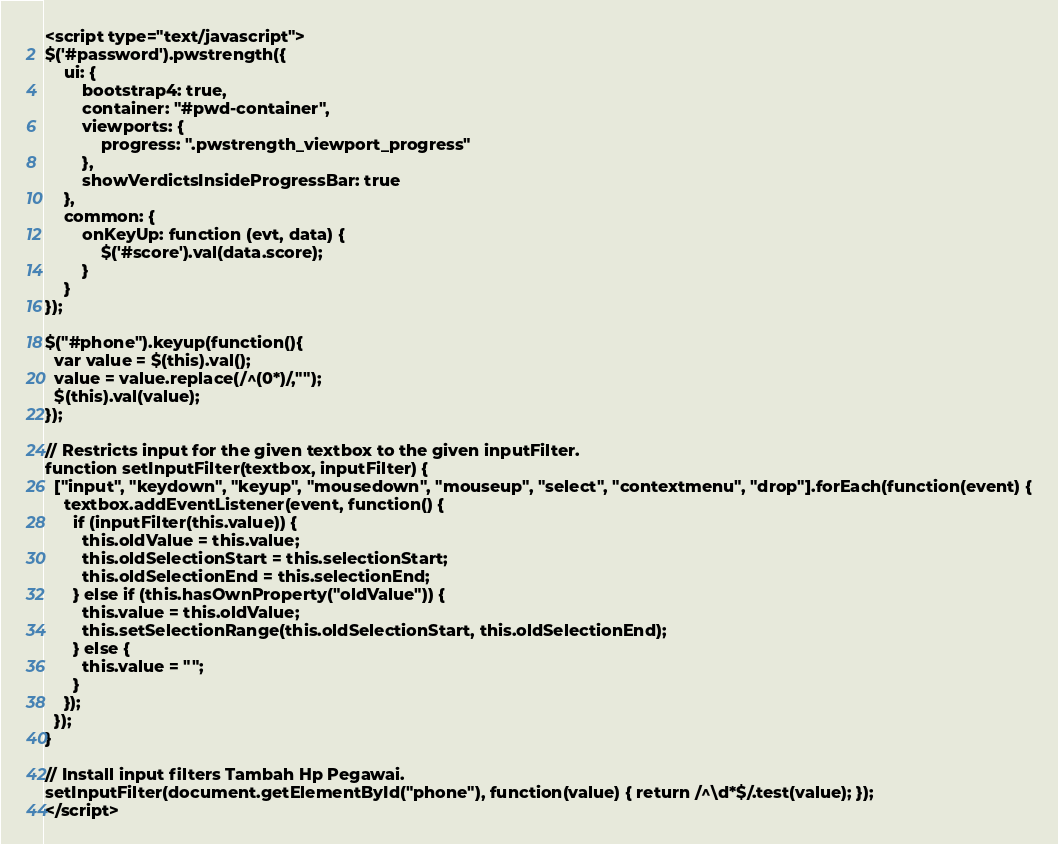Convert code to text. <code><loc_0><loc_0><loc_500><loc_500><_PHP_><script type="text/javascript">
$('#password').pwstrength({
    ui: {
        bootstrap4: true,
        container: "#pwd-container",
        viewports: {
            progress: ".pwstrength_viewport_progress"
        },
        showVerdictsInsideProgressBar: true
    },
    common: {
        onKeyUp: function (evt, data) {
            $('#score').val(data.score);
        }
    }
});

$("#phone").keyup(function(){
  var value = $(this).val();
  value = value.replace(/^(0*)/,"");
  $(this).val(value);
});

// Restricts input for the given textbox to the given inputFilter.
function setInputFilter(textbox, inputFilter) {
  ["input", "keydown", "keyup", "mousedown", "mouseup", "select", "contextmenu", "drop"].forEach(function(event) {
    textbox.addEventListener(event, function() {
      if (inputFilter(this.value)) {
        this.oldValue = this.value;
        this.oldSelectionStart = this.selectionStart;
        this.oldSelectionEnd = this.selectionEnd;
      } else if (this.hasOwnProperty("oldValue")) {
        this.value = this.oldValue;
        this.setSelectionRange(this.oldSelectionStart, this.oldSelectionEnd);
      } else {
        this.value = "";
      }
    });
  });
}

// Install input filters Tambah Hp Pegawai.
setInputFilter(document.getElementById("phone"), function(value) { return /^\d*$/.test(value); });
</script>
</code> 